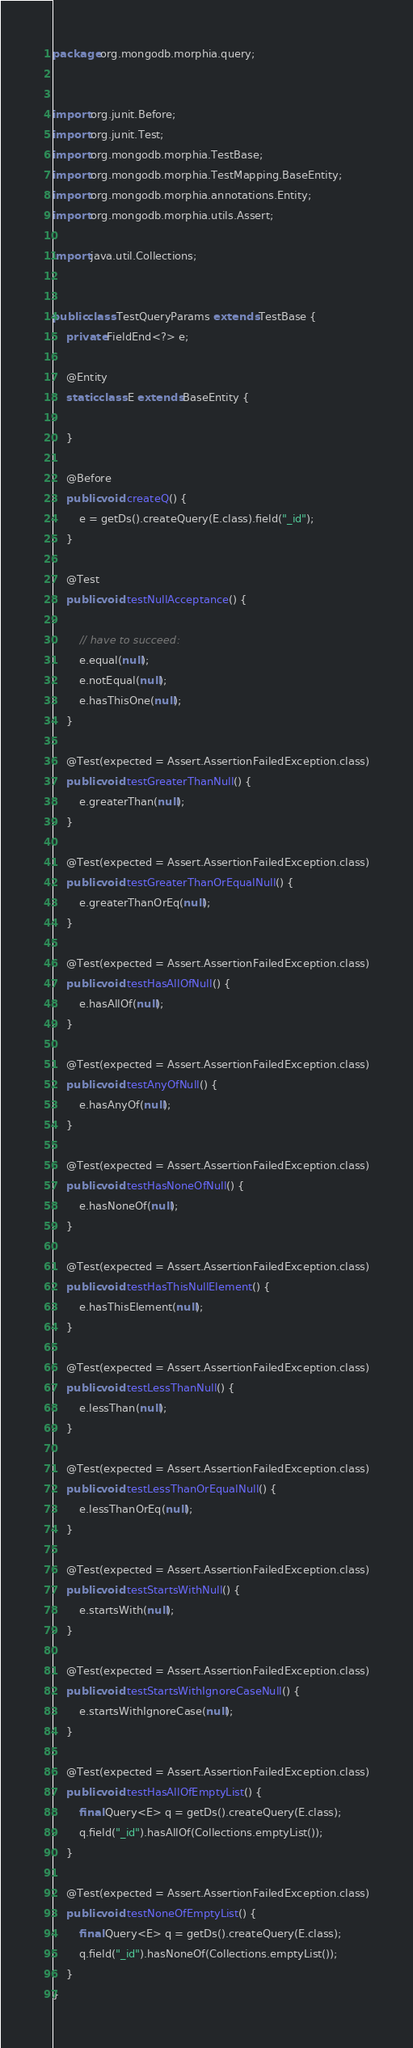Convert code to text. <code><loc_0><loc_0><loc_500><loc_500><_Java_>package org.mongodb.morphia.query;


import org.junit.Before;
import org.junit.Test;
import org.mongodb.morphia.TestBase;
import org.mongodb.morphia.TestMapping.BaseEntity;
import org.mongodb.morphia.annotations.Entity;
import org.mongodb.morphia.utils.Assert;

import java.util.Collections;


public class TestQueryParams extends TestBase {
    private FieldEnd<?> e;

    @Entity
    static class E extends BaseEntity {

    }

    @Before
    public void createQ() {
        e = getDs().createQuery(E.class).field("_id");
    }

    @Test
    public void testNullAcceptance() {

        // have to succeed:
        e.equal(null);
        e.notEqual(null);
        e.hasThisOne(null);
    }

    @Test(expected = Assert.AssertionFailedException.class)
    public void testGreaterThanNull() {
        e.greaterThan(null);
    }

    @Test(expected = Assert.AssertionFailedException.class)
    public void testGreaterThanOrEqualNull() {
        e.greaterThanOrEq(null);
    }

    @Test(expected = Assert.AssertionFailedException.class)
    public void testHasAllOfNull() {
        e.hasAllOf(null);
    }

    @Test(expected = Assert.AssertionFailedException.class)
    public void testAnyOfNull() {
        e.hasAnyOf(null);
    }

    @Test(expected = Assert.AssertionFailedException.class)
    public void testHasNoneOfNull() {
        e.hasNoneOf(null);
    }

    @Test(expected = Assert.AssertionFailedException.class)
    public void testHasThisNullElement() {
        e.hasThisElement(null);
    }

    @Test(expected = Assert.AssertionFailedException.class)
    public void testLessThanNull() {
        e.lessThan(null);
    }

    @Test(expected = Assert.AssertionFailedException.class)
    public void testLessThanOrEqualNull() {
        e.lessThanOrEq(null);
    }

    @Test(expected = Assert.AssertionFailedException.class)
    public void testStartsWithNull() {
        e.startsWith(null);
    }

    @Test(expected = Assert.AssertionFailedException.class)
    public void testStartsWithIgnoreCaseNull() {
        e.startsWithIgnoreCase(null);
    }

    @Test(expected = Assert.AssertionFailedException.class)
    public void testHasAllOfEmptyList() {
        final Query<E> q = getDs().createQuery(E.class);
        q.field("_id").hasAllOf(Collections.emptyList());
    }

    @Test(expected = Assert.AssertionFailedException.class)
    public void testNoneOfEmptyList() {
        final Query<E> q = getDs().createQuery(E.class);
        q.field("_id").hasNoneOf(Collections.emptyList());
    }
}
</code> 